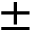Convert formula to latex. <formula><loc_0><loc_0><loc_500><loc_500>\pm</formula> 